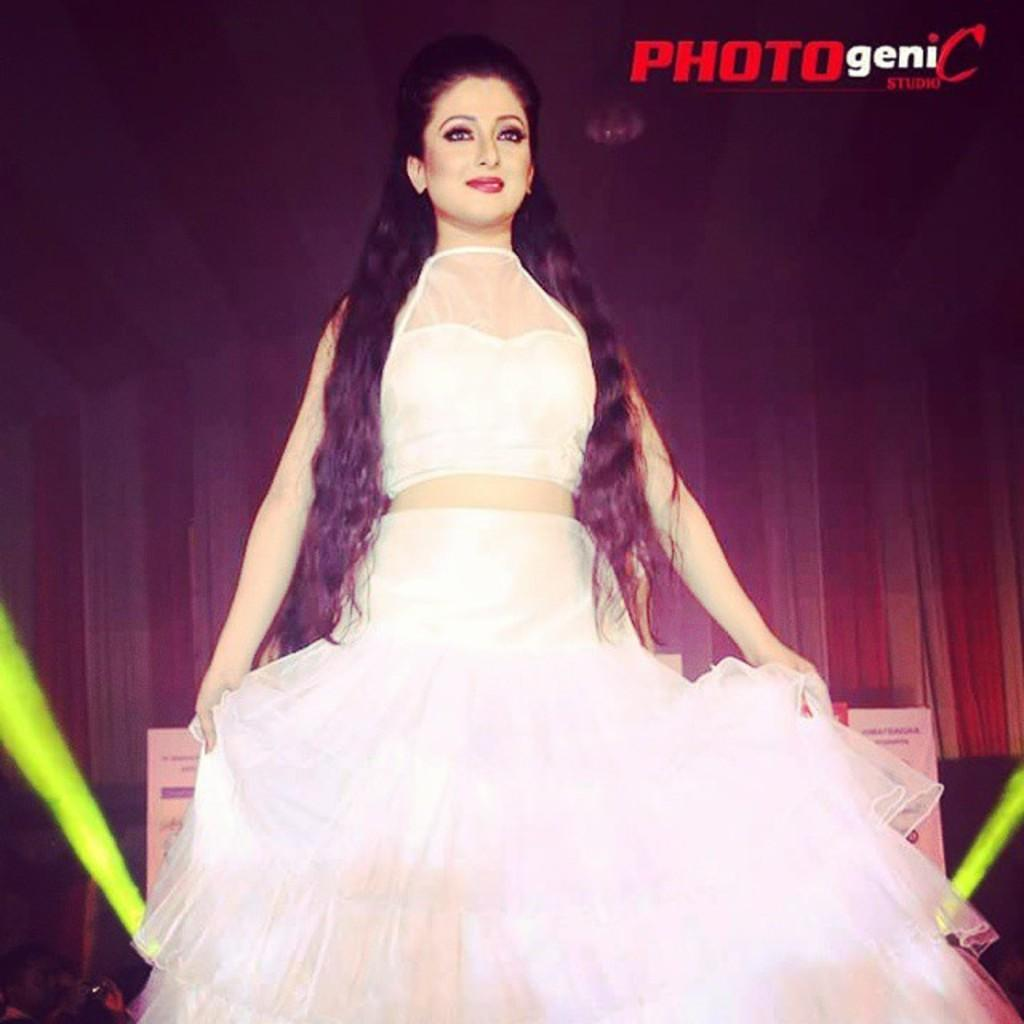What is the main subject of the image? There is a woman standing in the image. What is the woman wearing? The woman is wearing a white dress. Can you describe any additional features of the image? There is a watermark in the image. What can be seen in the background of the image? There are green-colored things in the background of the image. How many cherries can be seen falling from the sky in the image? There are no cherries visible in the image, nor are any falling from the sky. What type of sleet can be seen covering the ground in the image? There is no sleet present in the image; the ground is not visible. 